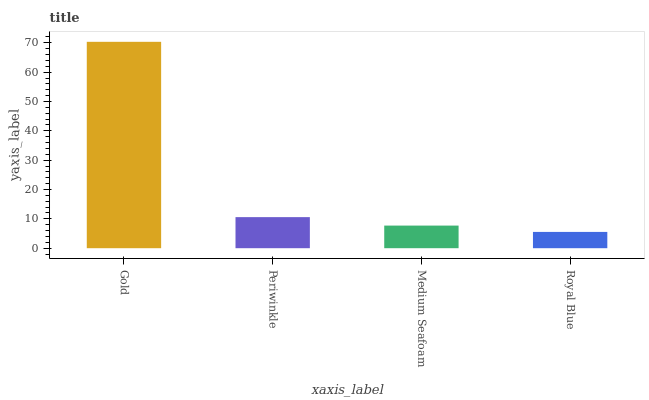Is Royal Blue the minimum?
Answer yes or no. Yes. Is Gold the maximum?
Answer yes or no. Yes. Is Periwinkle the minimum?
Answer yes or no. No. Is Periwinkle the maximum?
Answer yes or no. No. Is Gold greater than Periwinkle?
Answer yes or no. Yes. Is Periwinkle less than Gold?
Answer yes or no. Yes. Is Periwinkle greater than Gold?
Answer yes or no. No. Is Gold less than Periwinkle?
Answer yes or no. No. Is Periwinkle the high median?
Answer yes or no. Yes. Is Medium Seafoam the low median?
Answer yes or no. Yes. Is Royal Blue the high median?
Answer yes or no. No. Is Gold the low median?
Answer yes or no. No. 